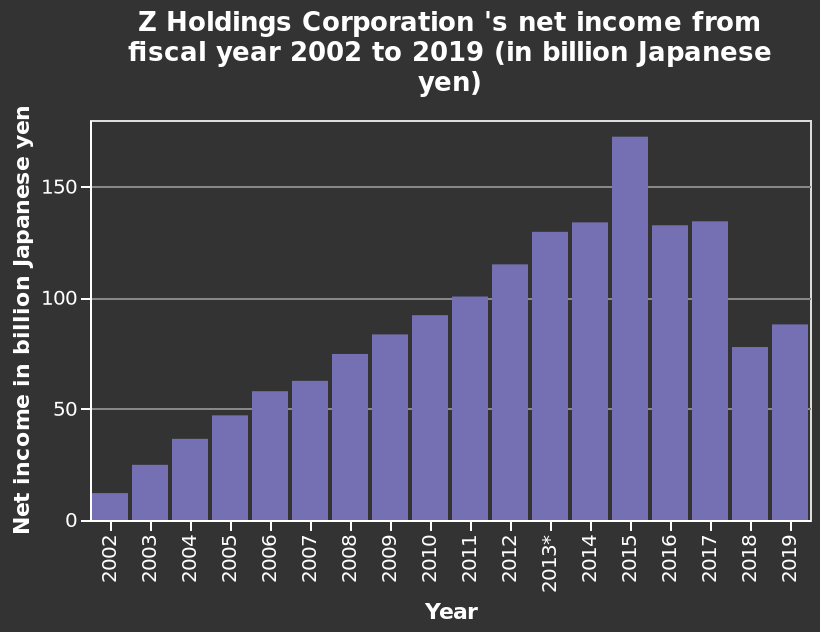<image>
please enumerates aspects of the construction of the chart This is a bar chart named Z Holdings Corporation 's net income from fiscal year 2002 to 2019 (in billion Japanese yen). The x-axis plots Year along a linear scale with a minimum of 2002 and a maximum of 2019. There is a linear scale from 0 to 150 on the y-axis, marked Net income in billion Japanese yen. Was there a consistent increase in income between 2002 and 2014? Yes, there was a relatively steady increase in income between 2002 and 2014. 